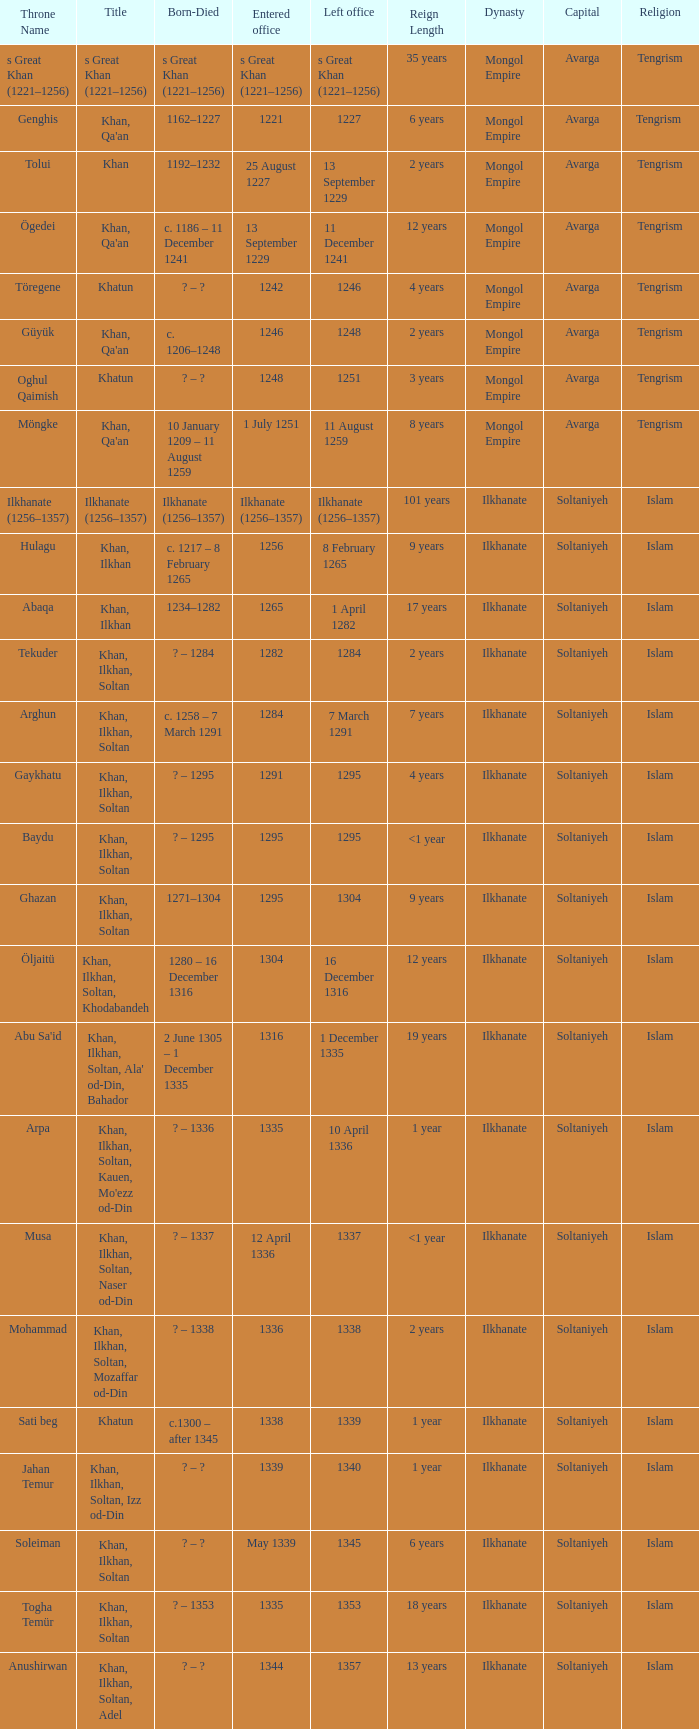What are the dates of birth and death for the person who entered office on 13 september 1229? C. 1186 – 11 december 1241. 